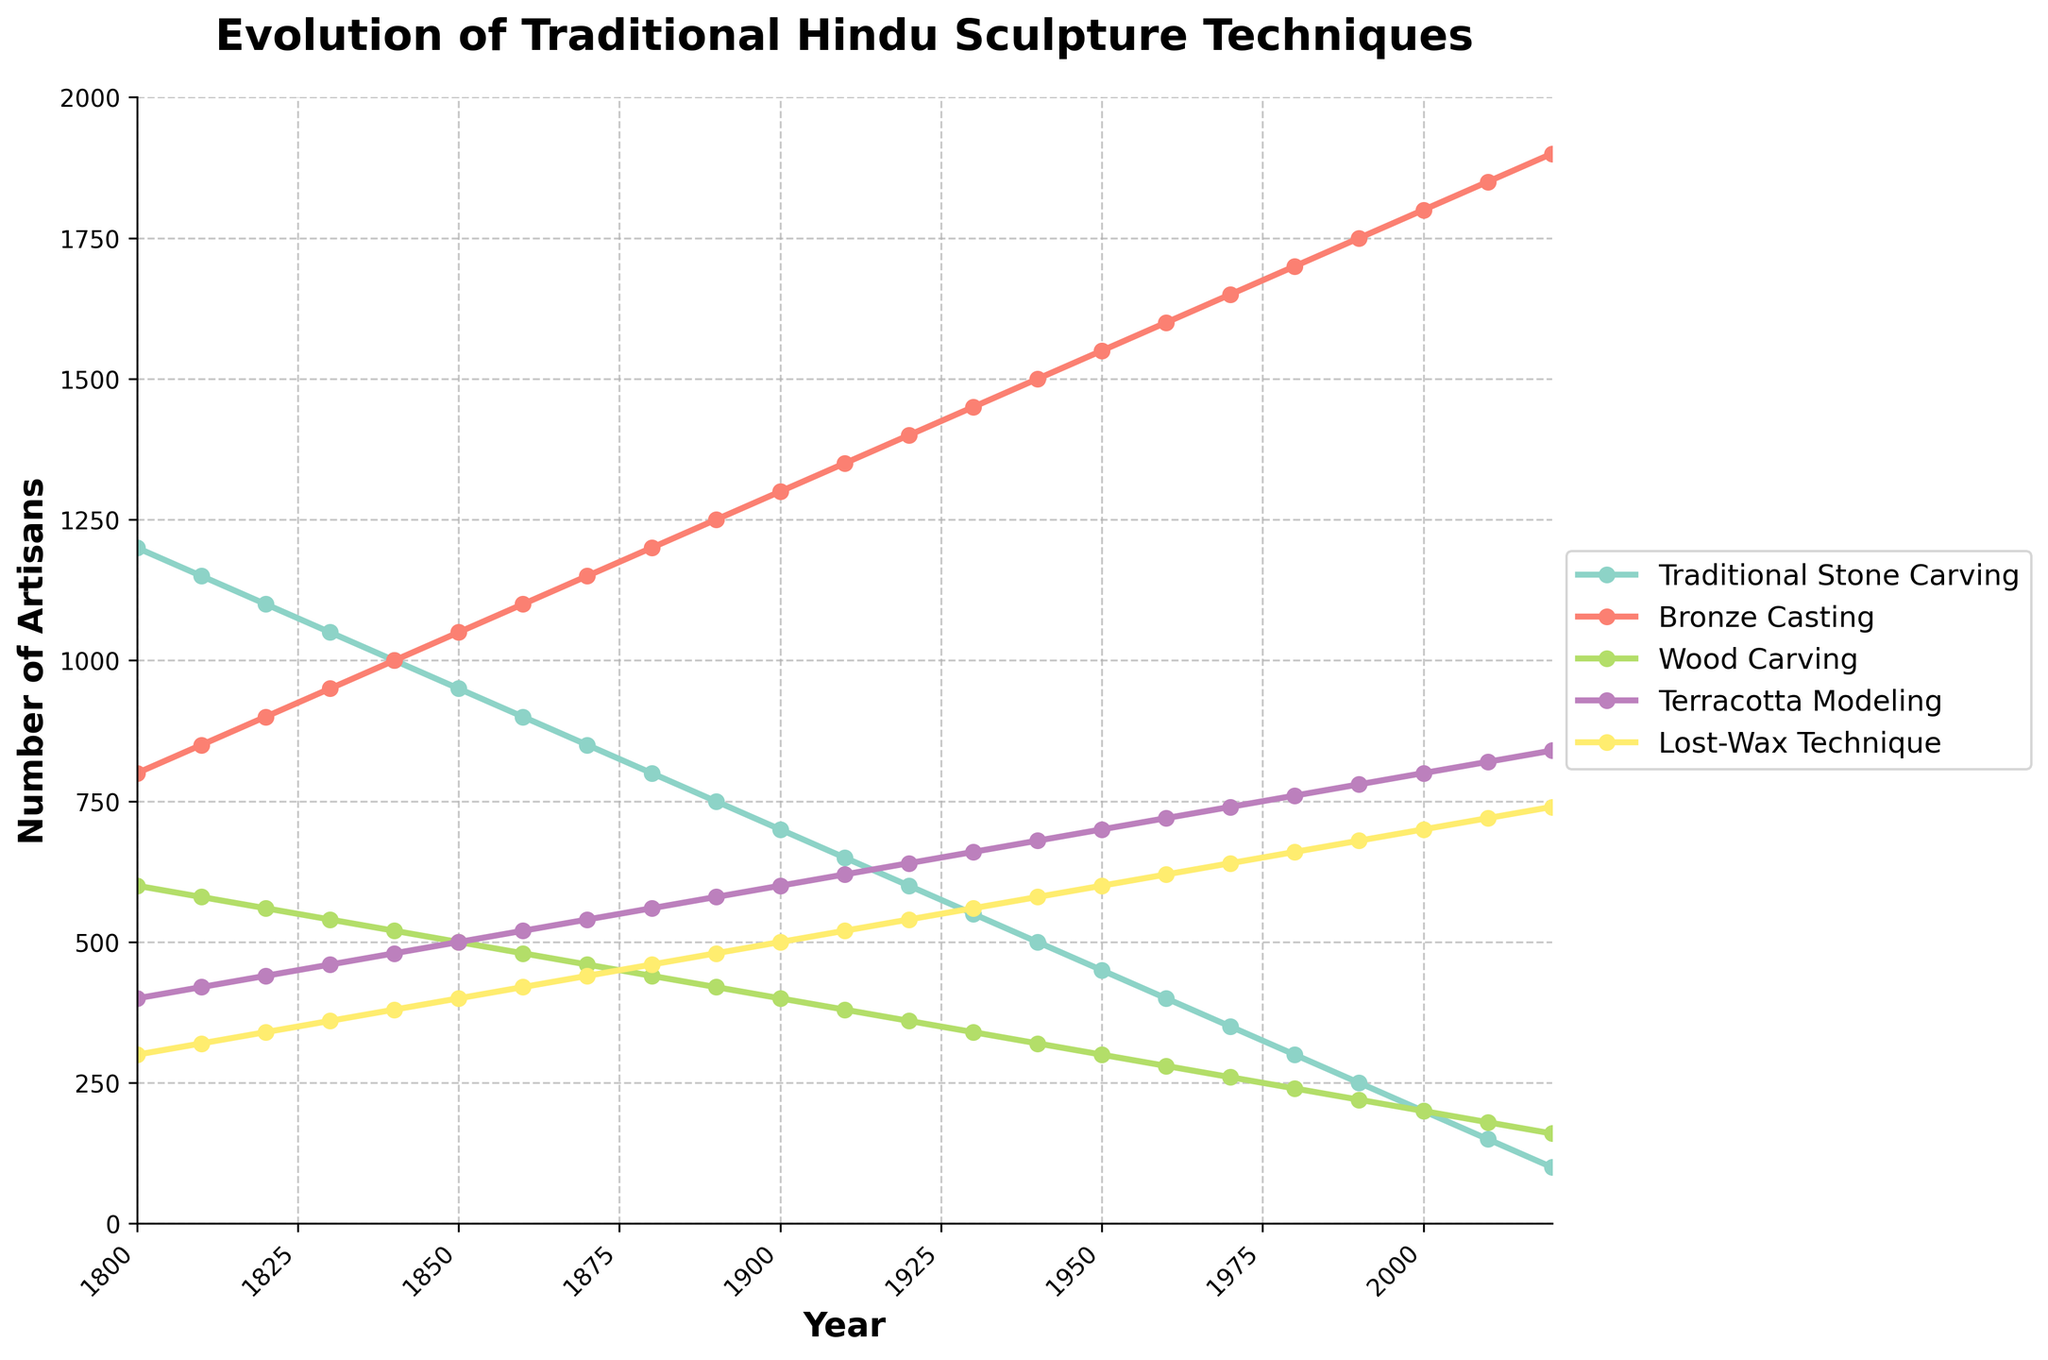What was the trend in the number of artisans using the Traditional Stone Carving technique from 1800 to 2020? The line chart for Traditional Stone Carving shows a steady decrease from 1200 artisans in 1800 to 100 artisans in 2020, indicating a declining trend over time.
Answer: Declining Which sculpture technique had the highest number of artisans in the year 1900? In 1900, the Bronze Casting technique had the highest number of artisans, visible as the topmost line among all techniques around that year, with 1300 artisans.
Answer: Bronze Casting How did the number of artisans using the Lost-Wax Technique change from 1940 to 1980? The Lost-Wax Technique shows a steady increase from 580 artisans in 1940 to 660 artisans in 1980, observed as a gradual upward slope in the corresponding line.
Answer: Increased Between 1850 and 1950, which technique experienced the most growth in artisans? Bronze Casting grew from 1050 artisans in 1850 to 1550 artisans in 1950. This growth of 500 artisans is the largest increase compared to the other techniques over this period.
Answer: Bronze Casting What is the difference in the number of artisans between the techniques of Wood Carving and Terracotta Modeling in the year 2020? In 2020, there were 160 artisans for Wood Carving and 840 artisans for Terracotta Modeling. The difference is calculated as 840 - 160 = 680 artisans.
Answer: 680 How does the visual representation of Traditional Stone Carving compare to Bronze Casting over the entire period? The Traditional Stone Carving line is consistently declining from the top to bottom, whereas the Bronze Casting line is consistently rising from lower to higher positions, indicating opposite trends.
Answer: Opposite trends What is the average number of artisans for Terracotta Modeling and Lost-Wax Technique in 1900? Terracotta Modeling had 600 artisans and Lost-Wax Technique had 500 artisans in 1900. The average is calculated as (600 + 500) / 2 = 550 artisans.
Answer: 550 By the year 2000, which technique saw the second highest number of artisans and how many were there? In 2000, the technique with the second highest number of artisans was Terracotta Modeling with 800 artisans, as it is the second topmost line around that year.
Answer: Terracotta Modeling, 800 How much did the number of artisans in Wood Carving decline from 1800 to 2020? In 1800, Wood Carving had 600 artisans and by 2020, it had 160 artisans. The decline is calculated as 600 - 160 = 440 artisans.
Answer: 440 Which technique had a steady increase in artisans, without a single decade of decline, from 1800 to 2020? The Lost-Wax Technique shows a consistent increase, as its line does not dip at any point from 1800 to 2020.
Answer: Lost-Wax Technique 